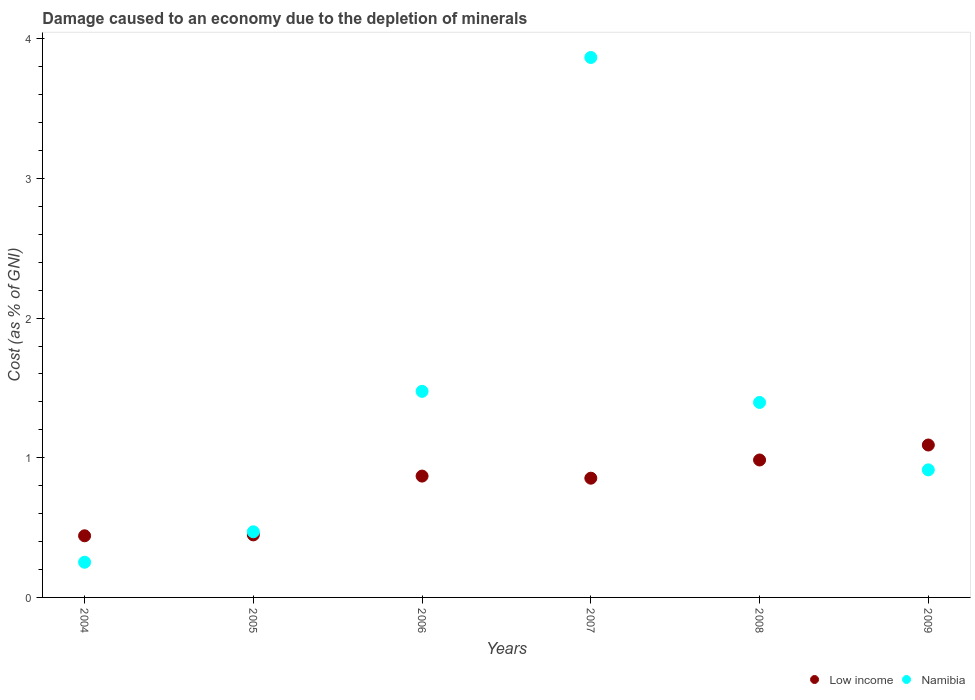Is the number of dotlines equal to the number of legend labels?
Make the answer very short. Yes. What is the cost of damage caused due to the depletion of minerals in Namibia in 2009?
Make the answer very short. 0.91. Across all years, what is the maximum cost of damage caused due to the depletion of minerals in Low income?
Provide a short and direct response. 1.09. Across all years, what is the minimum cost of damage caused due to the depletion of minerals in Namibia?
Provide a short and direct response. 0.25. In which year was the cost of damage caused due to the depletion of minerals in Low income maximum?
Make the answer very short. 2009. What is the total cost of damage caused due to the depletion of minerals in Low income in the graph?
Your response must be concise. 4.69. What is the difference between the cost of damage caused due to the depletion of minerals in Namibia in 2004 and that in 2005?
Provide a short and direct response. -0.22. What is the difference between the cost of damage caused due to the depletion of minerals in Namibia in 2005 and the cost of damage caused due to the depletion of minerals in Low income in 2008?
Make the answer very short. -0.51. What is the average cost of damage caused due to the depletion of minerals in Namibia per year?
Offer a terse response. 1.4. In the year 2007, what is the difference between the cost of damage caused due to the depletion of minerals in Low income and cost of damage caused due to the depletion of minerals in Namibia?
Your response must be concise. -3.01. What is the ratio of the cost of damage caused due to the depletion of minerals in Namibia in 2006 to that in 2007?
Make the answer very short. 0.38. What is the difference between the highest and the second highest cost of damage caused due to the depletion of minerals in Low income?
Provide a short and direct response. 0.11. What is the difference between the highest and the lowest cost of damage caused due to the depletion of minerals in Namibia?
Provide a succinct answer. 3.61. Is the cost of damage caused due to the depletion of minerals in Low income strictly greater than the cost of damage caused due to the depletion of minerals in Namibia over the years?
Give a very brief answer. No. Is the cost of damage caused due to the depletion of minerals in Namibia strictly less than the cost of damage caused due to the depletion of minerals in Low income over the years?
Offer a terse response. No. How many dotlines are there?
Provide a succinct answer. 2. Are the values on the major ticks of Y-axis written in scientific E-notation?
Offer a very short reply. No. How are the legend labels stacked?
Provide a succinct answer. Horizontal. What is the title of the graph?
Keep it short and to the point. Damage caused to an economy due to the depletion of minerals. Does "Mali" appear as one of the legend labels in the graph?
Offer a terse response. No. What is the label or title of the X-axis?
Ensure brevity in your answer.  Years. What is the label or title of the Y-axis?
Provide a short and direct response. Cost (as % of GNI). What is the Cost (as % of GNI) in Low income in 2004?
Your answer should be compact. 0.44. What is the Cost (as % of GNI) of Namibia in 2004?
Offer a very short reply. 0.25. What is the Cost (as % of GNI) of Low income in 2005?
Provide a short and direct response. 0.45. What is the Cost (as % of GNI) in Namibia in 2005?
Provide a succinct answer. 0.47. What is the Cost (as % of GNI) in Low income in 2006?
Offer a terse response. 0.87. What is the Cost (as % of GNI) of Namibia in 2006?
Give a very brief answer. 1.48. What is the Cost (as % of GNI) in Low income in 2007?
Provide a short and direct response. 0.85. What is the Cost (as % of GNI) of Namibia in 2007?
Provide a succinct answer. 3.87. What is the Cost (as % of GNI) in Low income in 2008?
Your answer should be compact. 0.98. What is the Cost (as % of GNI) in Namibia in 2008?
Your answer should be very brief. 1.4. What is the Cost (as % of GNI) in Low income in 2009?
Provide a short and direct response. 1.09. What is the Cost (as % of GNI) of Namibia in 2009?
Make the answer very short. 0.91. Across all years, what is the maximum Cost (as % of GNI) of Low income?
Your response must be concise. 1.09. Across all years, what is the maximum Cost (as % of GNI) in Namibia?
Offer a very short reply. 3.87. Across all years, what is the minimum Cost (as % of GNI) in Low income?
Give a very brief answer. 0.44. Across all years, what is the minimum Cost (as % of GNI) in Namibia?
Your response must be concise. 0.25. What is the total Cost (as % of GNI) in Low income in the graph?
Your response must be concise. 4.69. What is the total Cost (as % of GNI) in Namibia in the graph?
Give a very brief answer. 8.37. What is the difference between the Cost (as % of GNI) in Low income in 2004 and that in 2005?
Keep it short and to the point. -0.01. What is the difference between the Cost (as % of GNI) in Namibia in 2004 and that in 2005?
Provide a short and direct response. -0.22. What is the difference between the Cost (as % of GNI) of Low income in 2004 and that in 2006?
Your response must be concise. -0.43. What is the difference between the Cost (as % of GNI) of Namibia in 2004 and that in 2006?
Give a very brief answer. -1.22. What is the difference between the Cost (as % of GNI) in Low income in 2004 and that in 2007?
Offer a terse response. -0.41. What is the difference between the Cost (as % of GNI) in Namibia in 2004 and that in 2007?
Keep it short and to the point. -3.61. What is the difference between the Cost (as % of GNI) of Low income in 2004 and that in 2008?
Provide a short and direct response. -0.54. What is the difference between the Cost (as % of GNI) in Namibia in 2004 and that in 2008?
Your response must be concise. -1.14. What is the difference between the Cost (as % of GNI) in Low income in 2004 and that in 2009?
Your answer should be very brief. -0.65. What is the difference between the Cost (as % of GNI) in Namibia in 2004 and that in 2009?
Keep it short and to the point. -0.66. What is the difference between the Cost (as % of GNI) of Low income in 2005 and that in 2006?
Keep it short and to the point. -0.42. What is the difference between the Cost (as % of GNI) in Namibia in 2005 and that in 2006?
Your response must be concise. -1.01. What is the difference between the Cost (as % of GNI) of Low income in 2005 and that in 2007?
Your answer should be compact. -0.41. What is the difference between the Cost (as % of GNI) of Namibia in 2005 and that in 2007?
Provide a short and direct response. -3.4. What is the difference between the Cost (as % of GNI) of Low income in 2005 and that in 2008?
Give a very brief answer. -0.54. What is the difference between the Cost (as % of GNI) of Namibia in 2005 and that in 2008?
Your answer should be very brief. -0.93. What is the difference between the Cost (as % of GNI) in Low income in 2005 and that in 2009?
Give a very brief answer. -0.64. What is the difference between the Cost (as % of GNI) in Namibia in 2005 and that in 2009?
Provide a succinct answer. -0.44. What is the difference between the Cost (as % of GNI) of Low income in 2006 and that in 2007?
Your response must be concise. 0.02. What is the difference between the Cost (as % of GNI) in Namibia in 2006 and that in 2007?
Provide a succinct answer. -2.39. What is the difference between the Cost (as % of GNI) of Low income in 2006 and that in 2008?
Offer a terse response. -0.12. What is the difference between the Cost (as % of GNI) in Namibia in 2006 and that in 2008?
Your response must be concise. 0.08. What is the difference between the Cost (as % of GNI) of Low income in 2006 and that in 2009?
Ensure brevity in your answer.  -0.22. What is the difference between the Cost (as % of GNI) in Namibia in 2006 and that in 2009?
Give a very brief answer. 0.56. What is the difference between the Cost (as % of GNI) of Low income in 2007 and that in 2008?
Make the answer very short. -0.13. What is the difference between the Cost (as % of GNI) in Namibia in 2007 and that in 2008?
Your response must be concise. 2.47. What is the difference between the Cost (as % of GNI) of Low income in 2007 and that in 2009?
Your answer should be very brief. -0.24. What is the difference between the Cost (as % of GNI) in Namibia in 2007 and that in 2009?
Keep it short and to the point. 2.95. What is the difference between the Cost (as % of GNI) in Low income in 2008 and that in 2009?
Your answer should be compact. -0.11. What is the difference between the Cost (as % of GNI) in Namibia in 2008 and that in 2009?
Provide a succinct answer. 0.48. What is the difference between the Cost (as % of GNI) in Low income in 2004 and the Cost (as % of GNI) in Namibia in 2005?
Your answer should be compact. -0.03. What is the difference between the Cost (as % of GNI) of Low income in 2004 and the Cost (as % of GNI) of Namibia in 2006?
Your response must be concise. -1.03. What is the difference between the Cost (as % of GNI) of Low income in 2004 and the Cost (as % of GNI) of Namibia in 2007?
Make the answer very short. -3.42. What is the difference between the Cost (as % of GNI) of Low income in 2004 and the Cost (as % of GNI) of Namibia in 2008?
Provide a succinct answer. -0.95. What is the difference between the Cost (as % of GNI) of Low income in 2004 and the Cost (as % of GNI) of Namibia in 2009?
Keep it short and to the point. -0.47. What is the difference between the Cost (as % of GNI) in Low income in 2005 and the Cost (as % of GNI) in Namibia in 2006?
Keep it short and to the point. -1.03. What is the difference between the Cost (as % of GNI) in Low income in 2005 and the Cost (as % of GNI) in Namibia in 2007?
Provide a short and direct response. -3.42. What is the difference between the Cost (as % of GNI) in Low income in 2005 and the Cost (as % of GNI) in Namibia in 2008?
Offer a terse response. -0.95. What is the difference between the Cost (as % of GNI) of Low income in 2005 and the Cost (as % of GNI) of Namibia in 2009?
Your answer should be compact. -0.47. What is the difference between the Cost (as % of GNI) of Low income in 2006 and the Cost (as % of GNI) of Namibia in 2007?
Your answer should be compact. -3. What is the difference between the Cost (as % of GNI) of Low income in 2006 and the Cost (as % of GNI) of Namibia in 2008?
Your response must be concise. -0.53. What is the difference between the Cost (as % of GNI) in Low income in 2006 and the Cost (as % of GNI) in Namibia in 2009?
Offer a very short reply. -0.04. What is the difference between the Cost (as % of GNI) in Low income in 2007 and the Cost (as % of GNI) in Namibia in 2008?
Ensure brevity in your answer.  -0.54. What is the difference between the Cost (as % of GNI) in Low income in 2007 and the Cost (as % of GNI) in Namibia in 2009?
Make the answer very short. -0.06. What is the difference between the Cost (as % of GNI) in Low income in 2008 and the Cost (as % of GNI) in Namibia in 2009?
Ensure brevity in your answer.  0.07. What is the average Cost (as % of GNI) in Low income per year?
Offer a very short reply. 0.78. What is the average Cost (as % of GNI) of Namibia per year?
Offer a terse response. 1.4. In the year 2004, what is the difference between the Cost (as % of GNI) of Low income and Cost (as % of GNI) of Namibia?
Give a very brief answer. 0.19. In the year 2005, what is the difference between the Cost (as % of GNI) in Low income and Cost (as % of GNI) in Namibia?
Offer a terse response. -0.02. In the year 2006, what is the difference between the Cost (as % of GNI) in Low income and Cost (as % of GNI) in Namibia?
Your answer should be compact. -0.61. In the year 2007, what is the difference between the Cost (as % of GNI) in Low income and Cost (as % of GNI) in Namibia?
Your response must be concise. -3.01. In the year 2008, what is the difference between the Cost (as % of GNI) of Low income and Cost (as % of GNI) of Namibia?
Your response must be concise. -0.41. In the year 2009, what is the difference between the Cost (as % of GNI) in Low income and Cost (as % of GNI) in Namibia?
Provide a short and direct response. 0.18. What is the ratio of the Cost (as % of GNI) in Low income in 2004 to that in 2005?
Ensure brevity in your answer.  0.99. What is the ratio of the Cost (as % of GNI) of Namibia in 2004 to that in 2005?
Your answer should be compact. 0.54. What is the ratio of the Cost (as % of GNI) of Low income in 2004 to that in 2006?
Make the answer very short. 0.51. What is the ratio of the Cost (as % of GNI) in Namibia in 2004 to that in 2006?
Ensure brevity in your answer.  0.17. What is the ratio of the Cost (as % of GNI) of Low income in 2004 to that in 2007?
Ensure brevity in your answer.  0.52. What is the ratio of the Cost (as % of GNI) of Namibia in 2004 to that in 2007?
Provide a short and direct response. 0.07. What is the ratio of the Cost (as % of GNI) in Low income in 2004 to that in 2008?
Your answer should be very brief. 0.45. What is the ratio of the Cost (as % of GNI) in Namibia in 2004 to that in 2008?
Give a very brief answer. 0.18. What is the ratio of the Cost (as % of GNI) in Low income in 2004 to that in 2009?
Provide a succinct answer. 0.4. What is the ratio of the Cost (as % of GNI) of Namibia in 2004 to that in 2009?
Your answer should be very brief. 0.28. What is the ratio of the Cost (as % of GNI) in Low income in 2005 to that in 2006?
Provide a succinct answer. 0.52. What is the ratio of the Cost (as % of GNI) of Namibia in 2005 to that in 2006?
Provide a short and direct response. 0.32. What is the ratio of the Cost (as % of GNI) of Low income in 2005 to that in 2007?
Offer a terse response. 0.52. What is the ratio of the Cost (as % of GNI) in Namibia in 2005 to that in 2007?
Offer a terse response. 0.12. What is the ratio of the Cost (as % of GNI) in Low income in 2005 to that in 2008?
Give a very brief answer. 0.46. What is the ratio of the Cost (as % of GNI) of Namibia in 2005 to that in 2008?
Give a very brief answer. 0.34. What is the ratio of the Cost (as % of GNI) of Low income in 2005 to that in 2009?
Offer a terse response. 0.41. What is the ratio of the Cost (as % of GNI) in Namibia in 2005 to that in 2009?
Offer a very short reply. 0.51. What is the ratio of the Cost (as % of GNI) of Low income in 2006 to that in 2007?
Offer a terse response. 1.02. What is the ratio of the Cost (as % of GNI) of Namibia in 2006 to that in 2007?
Your answer should be very brief. 0.38. What is the ratio of the Cost (as % of GNI) in Low income in 2006 to that in 2008?
Keep it short and to the point. 0.88. What is the ratio of the Cost (as % of GNI) in Namibia in 2006 to that in 2008?
Your response must be concise. 1.06. What is the ratio of the Cost (as % of GNI) of Low income in 2006 to that in 2009?
Make the answer very short. 0.8. What is the ratio of the Cost (as % of GNI) of Namibia in 2006 to that in 2009?
Ensure brevity in your answer.  1.62. What is the ratio of the Cost (as % of GNI) in Low income in 2007 to that in 2008?
Offer a terse response. 0.87. What is the ratio of the Cost (as % of GNI) in Namibia in 2007 to that in 2008?
Provide a short and direct response. 2.77. What is the ratio of the Cost (as % of GNI) in Low income in 2007 to that in 2009?
Provide a short and direct response. 0.78. What is the ratio of the Cost (as % of GNI) of Namibia in 2007 to that in 2009?
Give a very brief answer. 4.23. What is the ratio of the Cost (as % of GNI) in Low income in 2008 to that in 2009?
Keep it short and to the point. 0.9. What is the ratio of the Cost (as % of GNI) in Namibia in 2008 to that in 2009?
Keep it short and to the point. 1.53. What is the difference between the highest and the second highest Cost (as % of GNI) in Low income?
Provide a succinct answer. 0.11. What is the difference between the highest and the second highest Cost (as % of GNI) in Namibia?
Offer a terse response. 2.39. What is the difference between the highest and the lowest Cost (as % of GNI) of Low income?
Provide a succinct answer. 0.65. What is the difference between the highest and the lowest Cost (as % of GNI) in Namibia?
Your response must be concise. 3.61. 